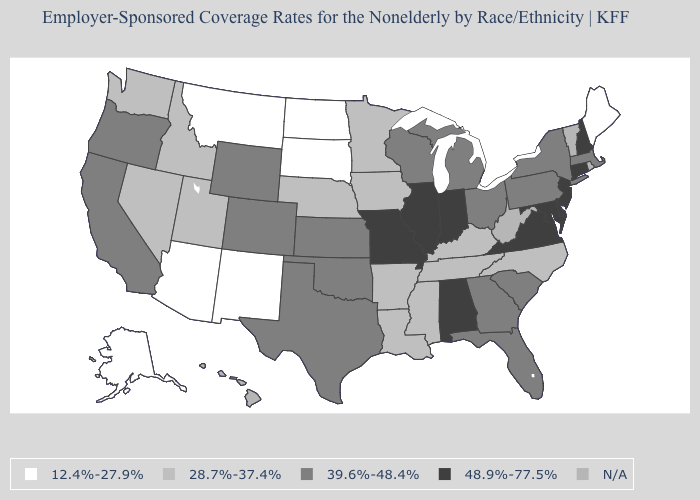Name the states that have a value in the range 48.9%-77.5%?
Write a very short answer. Alabama, Connecticut, Delaware, Illinois, Indiana, Maryland, Missouri, New Hampshire, New Jersey, Virginia. Does Oregon have the lowest value in the West?
Be succinct. No. What is the value of New Hampshire?
Write a very short answer. 48.9%-77.5%. Which states have the lowest value in the West?
Concise answer only. Alaska, Arizona, Montana, New Mexico. Name the states that have a value in the range 28.7%-37.4%?
Be succinct. Arkansas, Idaho, Iowa, Kentucky, Louisiana, Minnesota, Mississippi, Nebraska, Nevada, North Carolina, Tennessee, Utah, Washington. What is the value of Tennessee?
Write a very short answer. 28.7%-37.4%. What is the lowest value in the South?
Concise answer only. 28.7%-37.4%. What is the value of Illinois?
Give a very brief answer. 48.9%-77.5%. Does the first symbol in the legend represent the smallest category?
Give a very brief answer. Yes. Among the states that border South Dakota , which have the highest value?
Short answer required. Wyoming. What is the value of New Jersey?
Keep it brief. 48.9%-77.5%. Which states have the lowest value in the USA?
Keep it brief. Alaska, Arizona, Maine, Montana, New Mexico, North Dakota, South Dakota. What is the value of Ohio?
Short answer required. 39.6%-48.4%. 